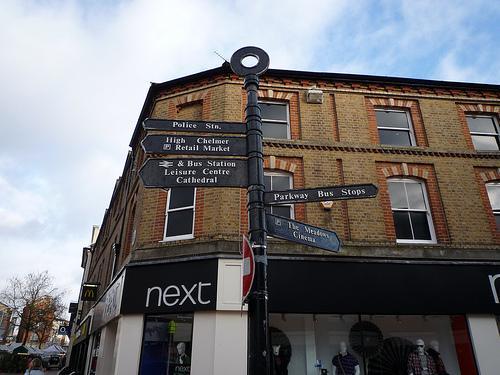How many mannequins are there?
Give a very brief answer. 2. 